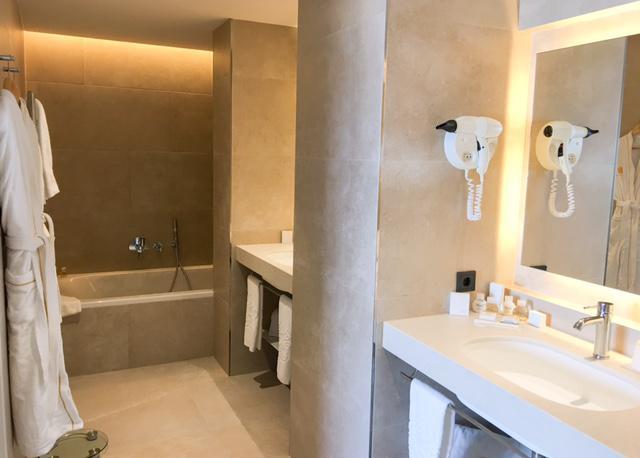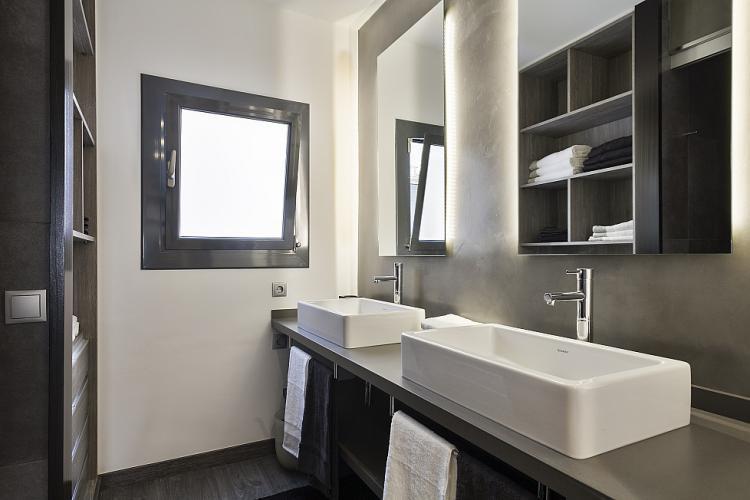The first image is the image on the left, the second image is the image on the right. Given the left and right images, does the statement "There are four faucets" hold true? Answer yes or no. No. The first image is the image on the left, the second image is the image on the right. Examine the images to the left and right. Is the description "There are two separate but raised square sinks sitting on top of a wooden cabinet facing front left." accurate? Answer yes or no. Yes. 